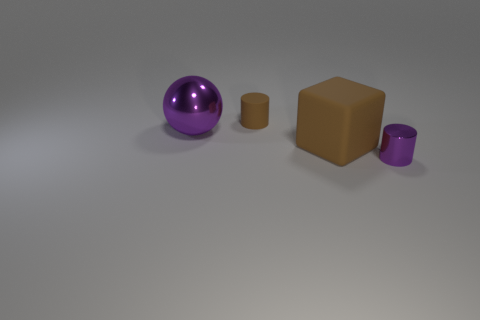Is the shape of the purple metal object in front of the large purple thing the same as  the small brown object?
Keep it short and to the point. Yes. Does the tiny metallic thing have the same shape as the tiny brown matte thing?
Your answer should be very brief. Yes. Is there another object that has the same shape as the big matte object?
Keep it short and to the point. No. There is a small object that is in front of the shiny thing left of the big brown object; what shape is it?
Your answer should be compact. Cylinder. What color is the metal object that is in front of the large brown rubber cube?
Offer a very short reply. Purple. What size is the purple ball that is the same material as the small purple object?
Ensure brevity in your answer.  Large. What is the size of the purple metallic thing that is the same shape as the tiny brown rubber thing?
Provide a succinct answer. Small. Are there any big brown matte blocks?
Provide a succinct answer. Yes. What number of objects are either rubber things on the right side of the small brown object or small cyan rubber cubes?
Offer a very short reply. 1. There is a thing that is the same size as the rubber cube; what is its material?
Your answer should be very brief. Metal. 